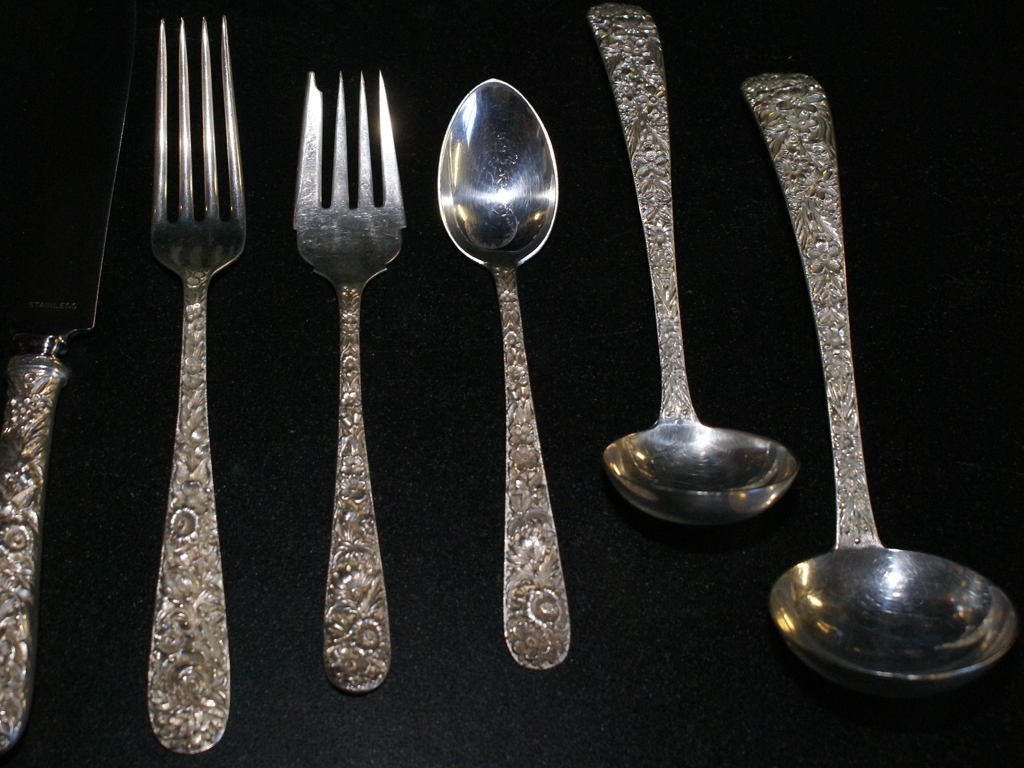Can you describe the pattern on the cutlery handles? The pattern on the cutlery handles is intricate and decorative, featuring floral motifs and vine-like details that give them an elegant and sophisticated appearance. 